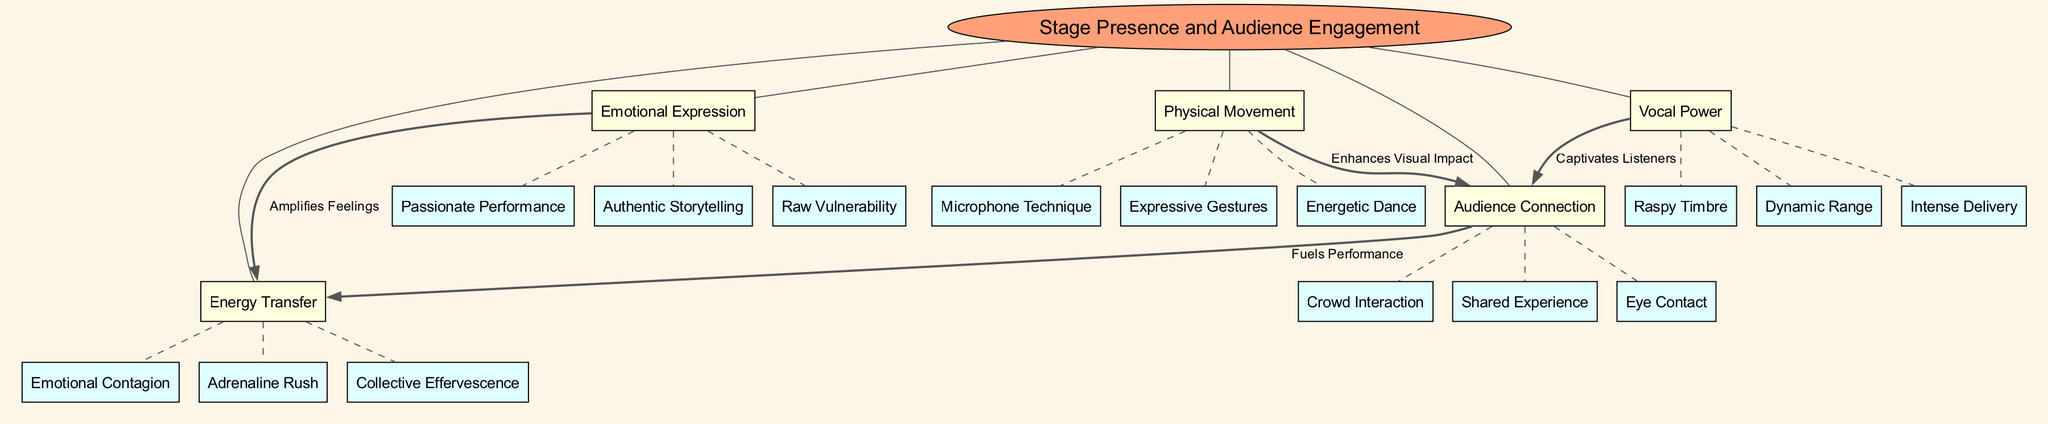What is the central concept of the diagram? The diagram's central concept is explicitly labeled as "Stage Presence and Audience Engagement." Therefore, by looking at the title within the diagram, one can directly identify this central theme.
Answer: Stage Presence and Audience Engagement How many main nodes are there in the diagram? The diagram lists five main nodes: Vocal Power, Emotional Expression, Physical Movement, Audience Connection, and Energy Transfer. By counting these distinct nodes, we arrive at the total number.
Answer: 5 Which node has "Raw Vulnerability" as a sub-node? Upon examining the sub-nodes, "Raw Vulnerability" is found under the "Emotional Expression" main node. Hence, the answer corresponds to that main node where this sub-node is categorized.
Answer: Emotional Expression What is the relationship labeled between "Vocal Power" and "Audience Connection"? The diagram indicates a connection between "Vocal Power" and "Audience Connection" with the label "Captivates Listeners." By referencing the connection arrows and their labels within the diagram, we derive the relationship in question.
Answer: Captivates Listeners What enhances visual impact according to the diagram? The diagram explicitly mentions that "Physical Movement" enhances visual impact, as indicated by the labeled connection. This indicates that the main node is linked to how visual elements improve engagement.
Answer: Physical Movement How does "Emotional Expression" influence "Energy Transfer"? The diagram specifies that "Emotional Expression" amplifies feelings, which in turn relates to "Energy Transfer." This is a reasoning question that requires connecting the influence of one main node on another according to the defined relationships.
Answer: Amplifies Feelings What connects "Audience Connection" and "Energy Transfer"? According to the diagram, the label "Fuels Performance" connects "Audience Connection" and "Energy Transfer." Therefore, by examining the nodes and their labels, we ascertain the specific linkage between these two concepts.
Answer: Fuels Performance Which sub-node is associated with "Intense Delivery"? In the diagram, "Intense Delivery" is directly listed as a sub-node under "Vocal Power." You can find this by looking at the sub-nodes associated with that main node.
Answer: Vocal Power 